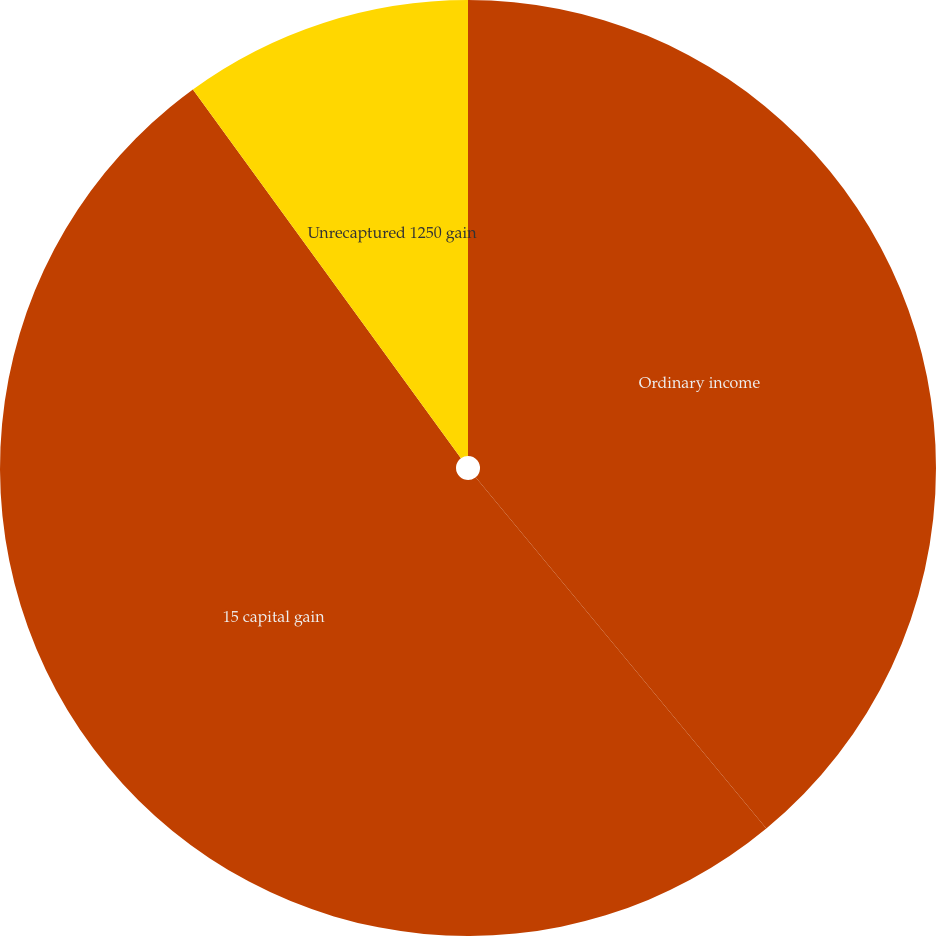<chart> <loc_0><loc_0><loc_500><loc_500><pie_chart><fcel>Ordinary income<fcel>15 capital gain<fcel>Unrecaptured 1250 gain<nl><fcel>39.0%<fcel>51.0%<fcel>10.0%<nl></chart> 